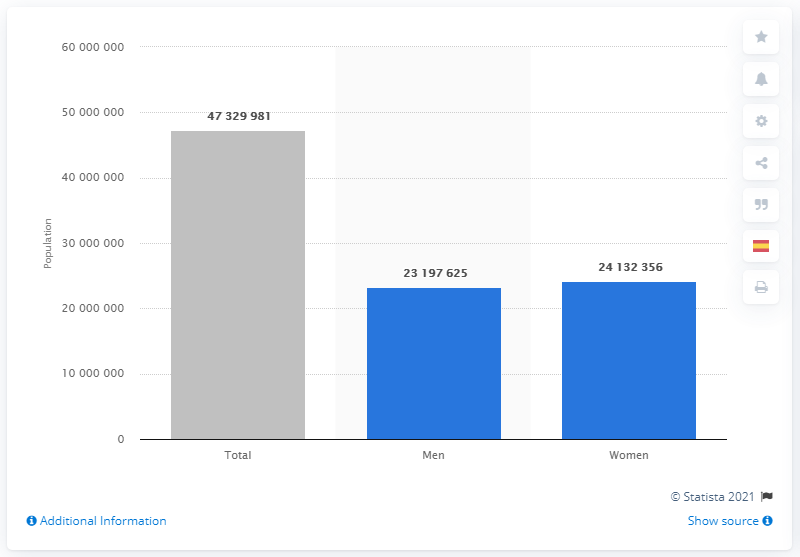Mention a couple of crucial points in this snapshot. As of July 2017, it is estimated that approximately 24,132,356 women lived in Spain. 